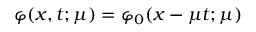Convert formula to latex. <formula><loc_0><loc_0><loc_500><loc_500>\varphi ( x , t ; \mu ) = \varphi _ { 0 } ( x - \mu t ; \mu )</formula> 